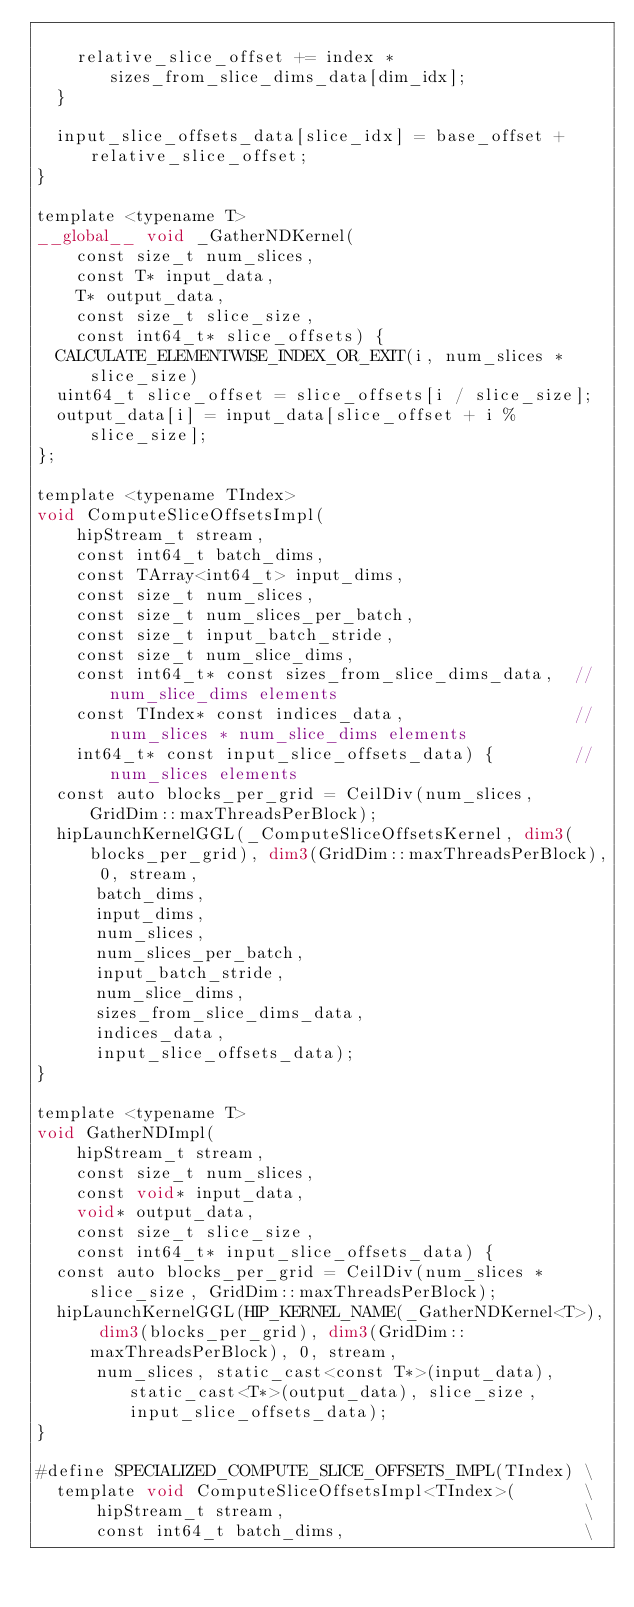<code> <loc_0><loc_0><loc_500><loc_500><_Cuda_>
    relative_slice_offset += index * sizes_from_slice_dims_data[dim_idx];
  }

  input_slice_offsets_data[slice_idx] = base_offset + relative_slice_offset;
}

template <typename T>
__global__ void _GatherNDKernel(
    const size_t num_slices,
    const T* input_data,
    T* output_data,
    const size_t slice_size,
    const int64_t* slice_offsets) {
  CALCULATE_ELEMENTWISE_INDEX_OR_EXIT(i, num_slices * slice_size)
  uint64_t slice_offset = slice_offsets[i / slice_size];
  output_data[i] = input_data[slice_offset + i % slice_size];
};

template <typename TIndex>
void ComputeSliceOffsetsImpl(
    hipStream_t stream,
    const int64_t batch_dims,
    const TArray<int64_t> input_dims,
    const size_t num_slices,
    const size_t num_slices_per_batch,
    const size_t input_batch_stride,
    const size_t num_slice_dims,
    const int64_t* const sizes_from_slice_dims_data,  // num_slice_dims elements
    const TIndex* const indices_data,                 // num_slices * num_slice_dims elements
    int64_t* const input_slice_offsets_data) {        // num_slices elements
  const auto blocks_per_grid = CeilDiv(num_slices, GridDim::maxThreadsPerBlock);
  hipLaunchKernelGGL(_ComputeSliceOffsetsKernel, dim3(blocks_per_grid), dim3(GridDim::maxThreadsPerBlock), 0, stream, 
      batch_dims,
      input_dims,
      num_slices,
      num_slices_per_batch,
      input_batch_stride,
      num_slice_dims,
      sizes_from_slice_dims_data,
      indices_data,
      input_slice_offsets_data);
}

template <typename T>
void GatherNDImpl(
    hipStream_t stream,
    const size_t num_slices,
    const void* input_data,
    void* output_data,
    const size_t slice_size,
    const int64_t* input_slice_offsets_data) {
  const auto blocks_per_grid = CeilDiv(num_slices * slice_size, GridDim::maxThreadsPerBlock);
  hipLaunchKernelGGL(HIP_KERNEL_NAME(_GatherNDKernel<T>), dim3(blocks_per_grid), dim3(GridDim::maxThreadsPerBlock), 0, stream, 
      num_slices, static_cast<const T*>(input_data), static_cast<T*>(output_data), slice_size, input_slice_offsets_data);
}

#define SPECIALIZED_COMPUTE_SLICE_OFFSETS_IMPL(TIndex) \
  template void ComputeSliceOffsetsImpl<TIndex>(       \
      hipStream_t stream,                              \
      const int64_t batch_dims,                        \</code> 